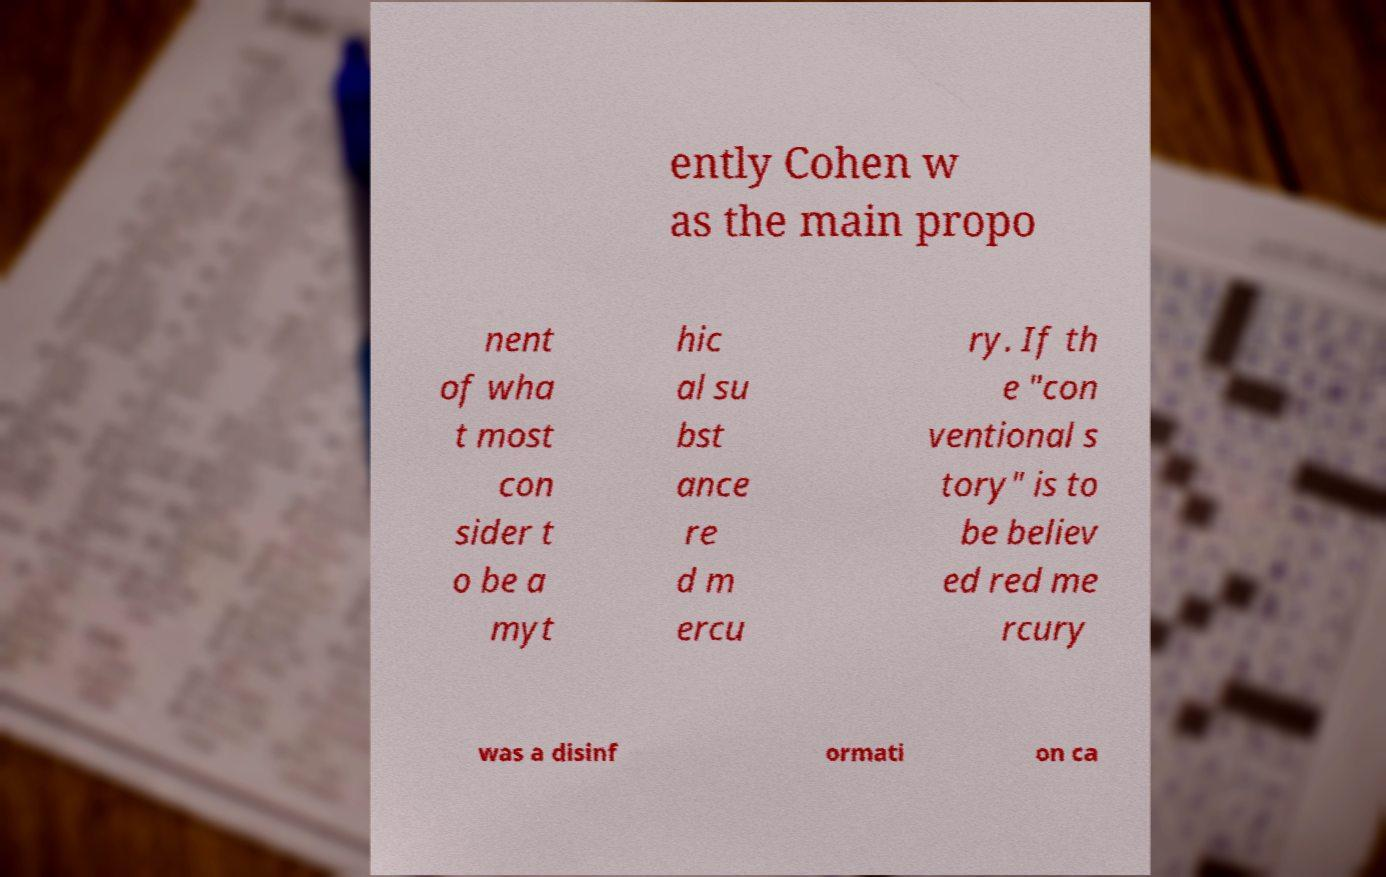Could you assist in decoding the text presented in this image and type it out clearly? ently Cohen w as the main propo nent of wha t most con sider t o be a myt hic al su bst ance re d m ercu ry. If th e "con ventional s tory" is to be believ ed red me rcury was a disinf ormati on ca 